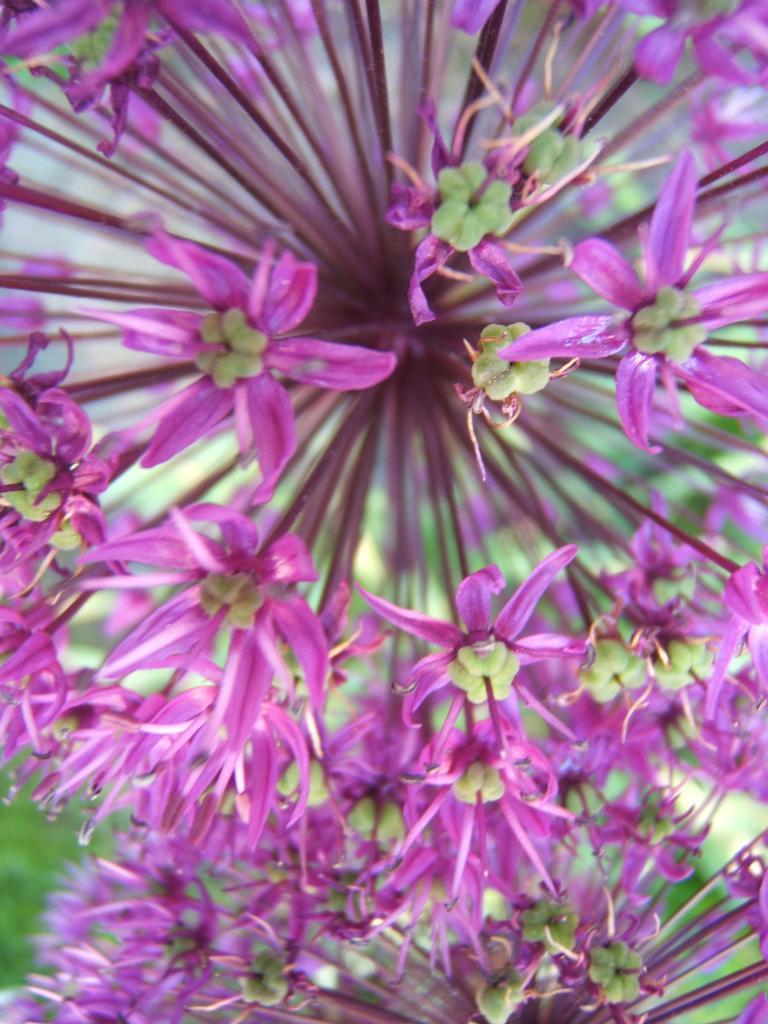Please provide a concise description of this image. In this image I can see few flowers. Its petals are in pink color. In the bottom left, I can see the grass. 